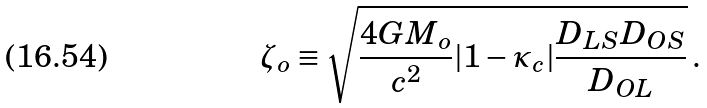Convert formula to latex. <formula><loc_0><loc_0><loc_500><loc_500>\zeta _ { o } \equiv \sqrt { \frac { 4 G M _ { o } } { c ^ { 2 } } | 1 - \kappa _ { c } | \frac { D _ { L S } D _ { O S } } { D _ { O L } } } \, .</formula> 